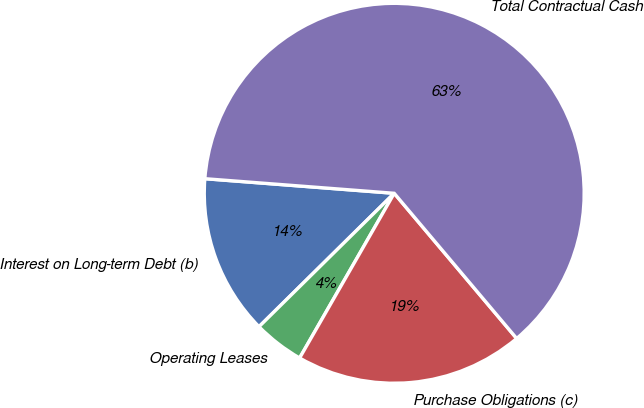Convert chart to OTSL. <chart><loc_0><loc_0><loc_500><loc_500><pie_chart><fcel>Interest on Long-term Debt (b)<fcel>Operating Leases<fcel>Purchase Obligations (c)<fcel>Total Contractual Cash<nl><fcel>13.62%<fcel>4.31%<fcel>19.45%<fcel>62.63%<nl></chart> 